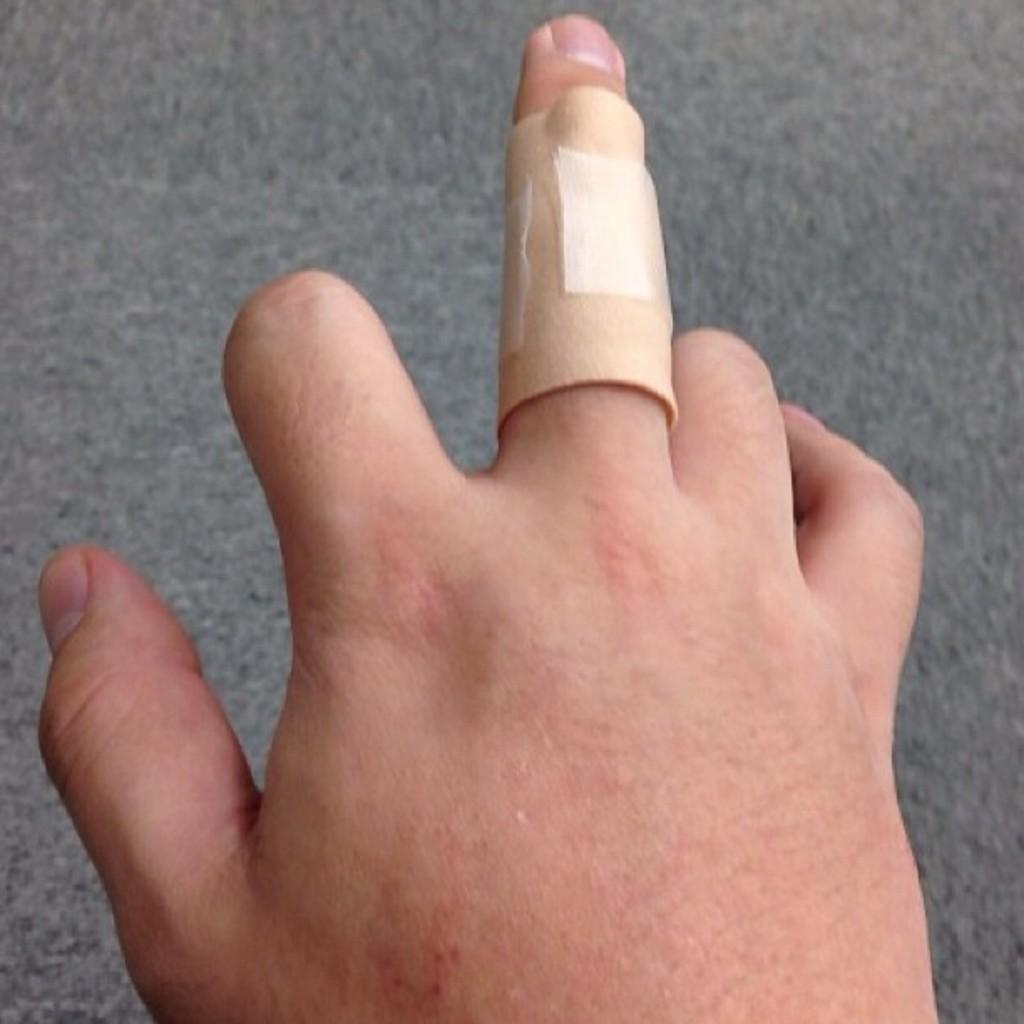Could you give a brief overview of what you see in this image? There is a band aid tied to the middle finger of a person's hand. 